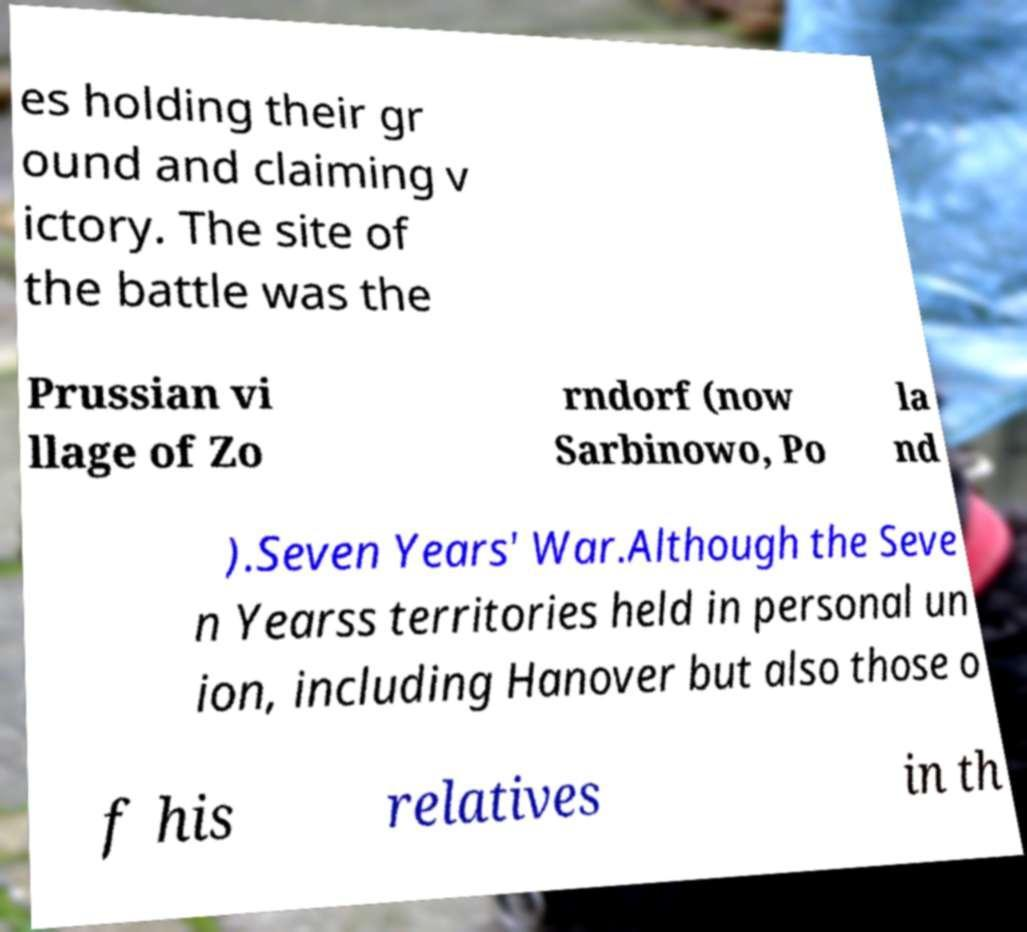I need the written content from this picture converted into text. Can you do that? es holding their gr ound and claiming v ictory. The site of the battle was the Prussian vi llage of Zo rndorf (now Sarbinowo, Po la nd ).Seven Years' War.Although the Seve n Yearss territories held in personal un ion, including Hanover but also those o f his relatives in th 